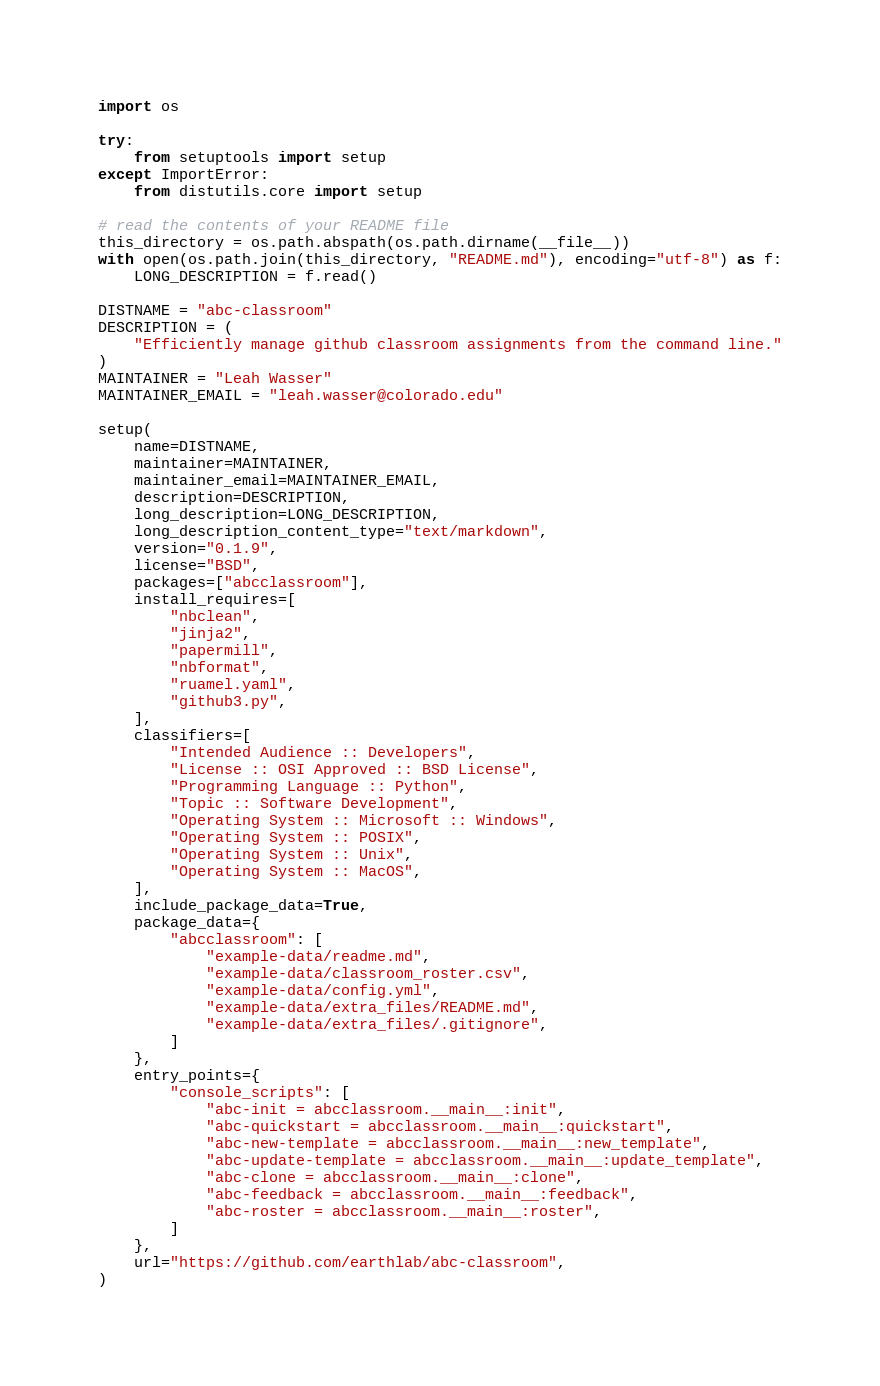Convert code to text. <code><loc_0><loc_0><loc_500><loc_500><_Python_>import os

try:
    from setuptools import setup
except ImportError:
    from distutils.core import setup

# read the contents of your README file
this_directory = os.path.abspath(os.path.dirname(__file__))
with open(os.path.join(this_directory, "README.md"), encoding="utf-8") as f:
    LONG_DESCRIPTION = f.read()

DISTNAME = "abc-classroom"
DESCRIPTION = (
    "Efficiently manage github classroom assignments from the command line."
)
MAINTAINER = "Leah Wasser"
MAINTAINER_EMAIL = "leah.wasser@colorado.edu"

setup(
    name=DISTNAME,
    maintainer=MAINTAINER,
    maintainer_email=MAINTAINER_EMAIL,
    description=DESCRIPTION,
    long_description=LONG_DESCRIPTION,
    long_description_content_type="text/markdown",
    version="0.1.9",
    license="BSD",
    packages=["abcclassroom"],
    install_requires=[
        "nbclean",
        "jinja2",
        "papermill",
        "nbformat",
        "ruamel.yaml",
        "github3.py",
    ],
    classifiers=[
        "Intended Audience :: Developers",
        "License :: OSI Approved :: BSD License",
        "Programming Language :: Python",
        "Topic :: Software Development",
        "Operating System :: Microsoft :: Windows",
        "Operating System :: POSIX",
        "Operating System :: Unix",
        "Operating System :: MacOS",
    ],
    include_package_data=True,
    package_data={
        "abcclassroom": [
            "example-data/readme.md",
            "example-data/classroom_roster.csv",
            "example-data/config.yml",
            "example-data/extra_files/README.md",
            "example-data/extra_files/.gitignore",
        ]
    },
    entry_points={
        "console_scripts": [
            "abc-init = abcclassroom.__main__:init",
            "abc-quickstart = abcclassroom.__main__:quickstart",
            "abc-new-template = abcclassroom.__main__:new_template",
            "abc-update-template = abcclassroom.__main__:update_template",
            "abc-clone = abcclassroom.__main__:clone",
            "abc-feedback = abcclassroom.__main__:feedback",
            "abc-roster = abcclassroom.__main__:roster",
        ]
    },
    url="https://github.com/earthlab/abc-classroom",
)
</code> 